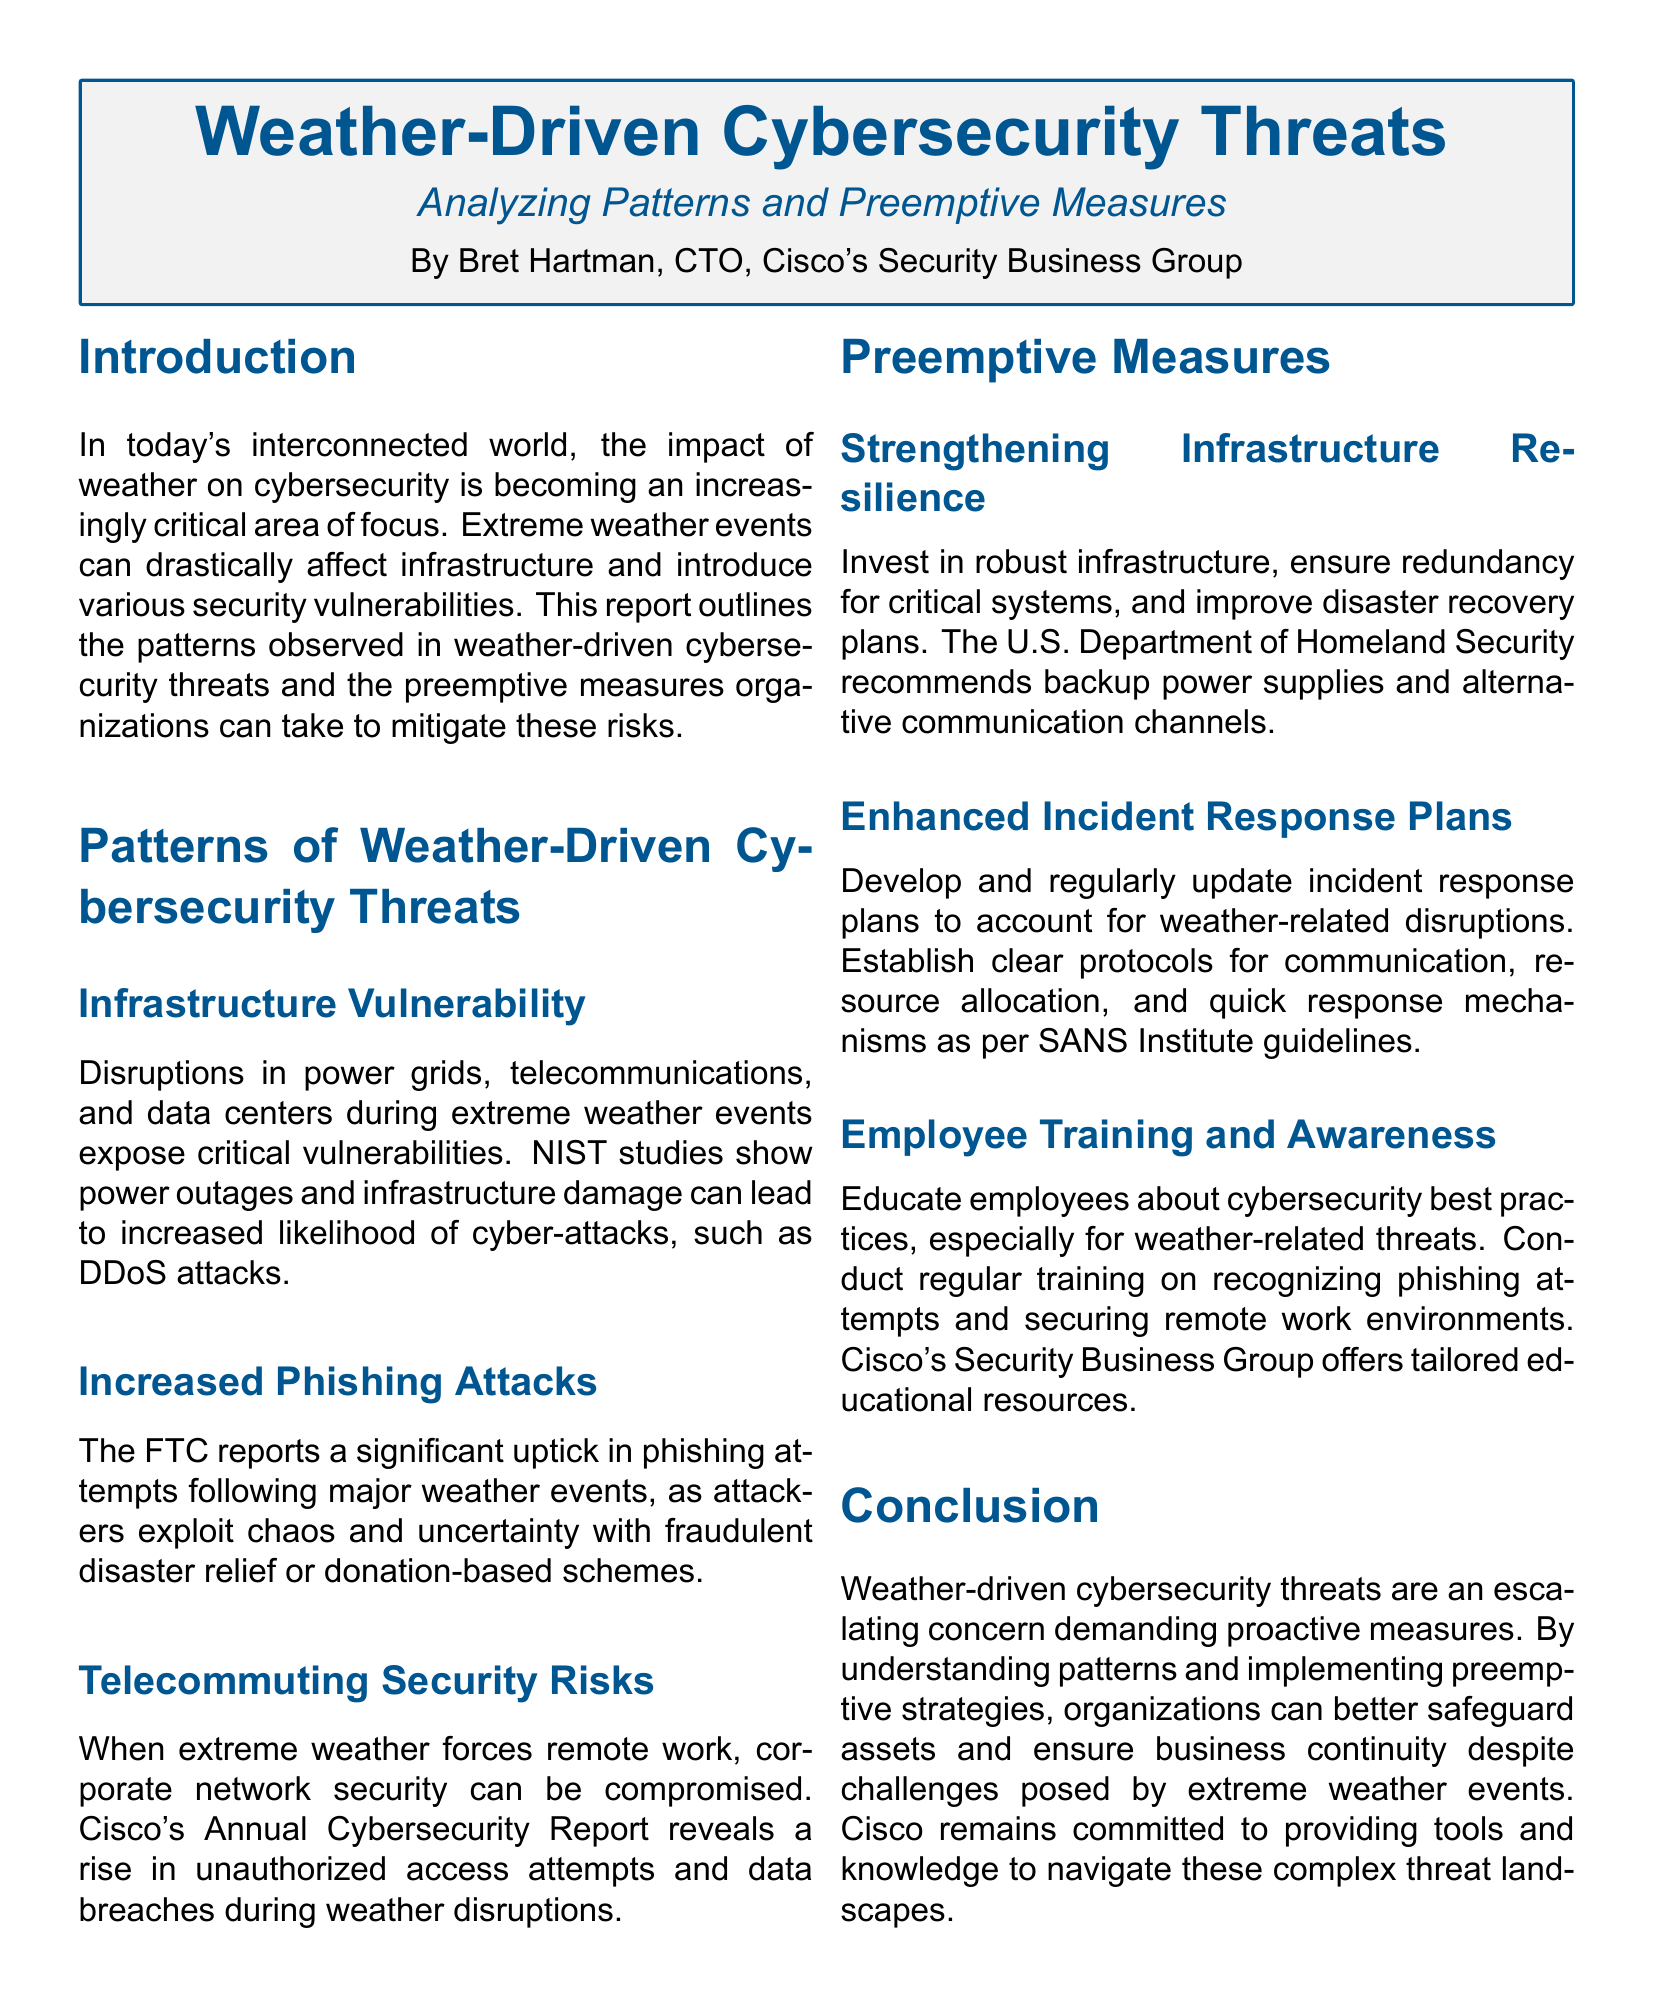What is the title of the report? The title of the report is introduced at the beginning of the document, clearly stated as "Weather-Driven Cybersecurity Threats".
Answer: Weather-Driven Cybersecurity Threats Who authored the report? The author is mentioned in the document, stating the name and position at Cisco.
Answer: Bret Hartman, CTO, Cisco's Security Business Group What is one example of a weather-driven cybersecurity threat identified in the report? The report lists specific types of cyber threats linked to weather events. One example is provided.
Answer: Increased Phishing Attacks What recommendation does the U.S. Department of Homeland Security make? The document mentions specific recommendations from the U.S. Department of Homeland Security regarding infrastructure.
Answer: Backup power supplies What is a suggested measure to address telecommuting security risks? The report emphasizes employee training on cybersecurity, particularly for remote work scenarios.
Answer: Employee Training and Awareness How does extreme weather affect infrastructure vulnerability? The document discusses the consequences of extreme weather events on infrastructure, leading to increased cyber threats.
Answer: Power outages What is the focus of the document? The document outlines the intersection of weather and cybersecurity, particularly how weather influences cyber threats.
Answer: Analyzing Patterns and Preemptive Measures What type of attacks saw an increase following major weather events? The document cites a significant rise in specific types of cyber threats after major weather events.
Answer: Phishing attempts What does the report suggest organizations should invest in? The report highlights a specific area organizations should focus on to improve resilience against weather-driven threats.
Answer: Robust infrastructure 